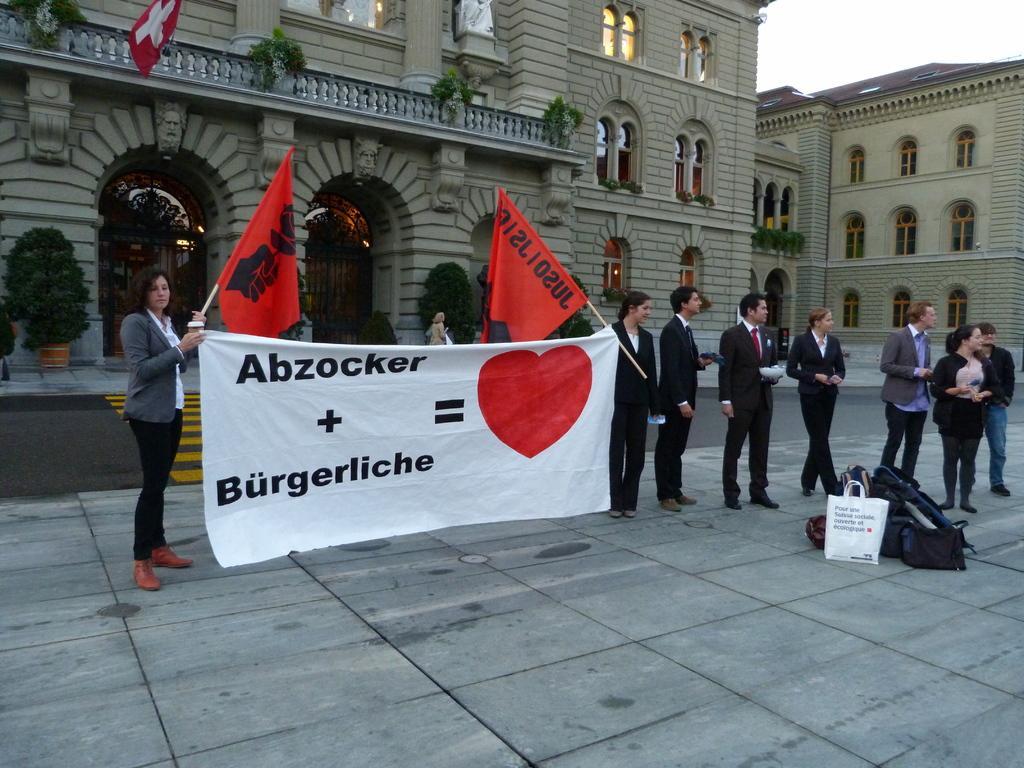Could you give a brief overview of what you see in this image? In this image there are two people holding the flags and a banner in their hands. Beside them there are a few people standing on the road. In front of them there are bags. Behind them there are a few people walking. There are flower pots, buildings and a flag. At the top of the image there is sky. 